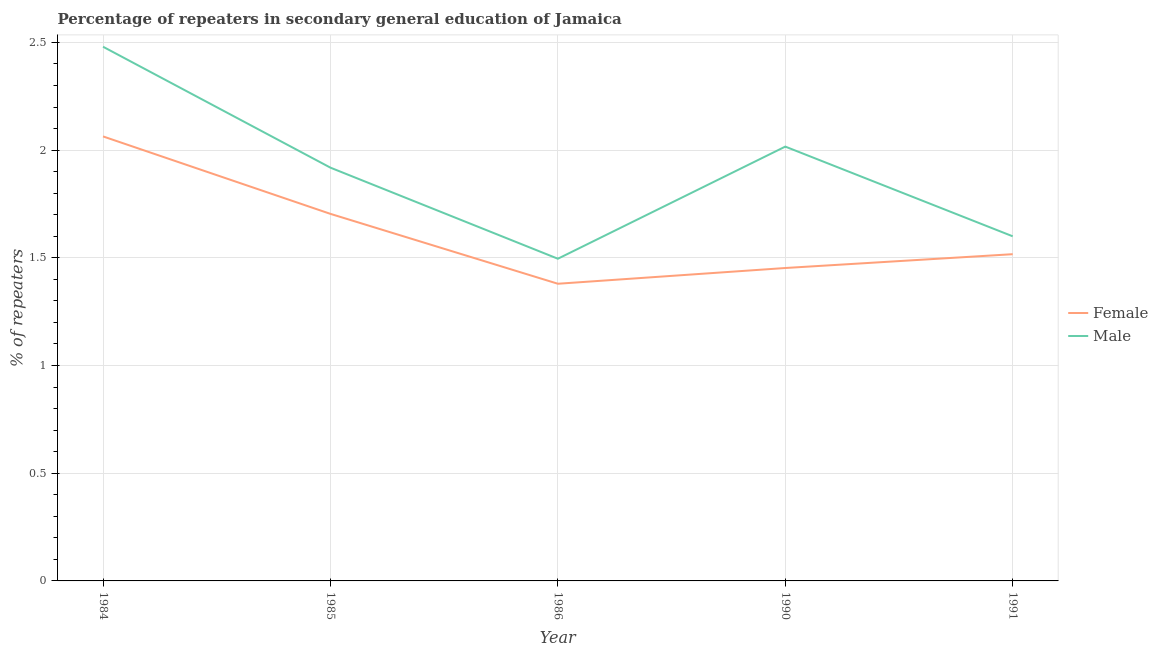How many different coloured lines are there?
Keep it short and to the point. 2. Does the line corresponding to percentage of male repeaters intersect with the line corresponding to percentage of female repeaters?
Your answer should be compact. No. What is the percentage of female repeaters in 1990?
Give a very brief answer. 1.45. Across all years, what is the maximum percentage of female repeaters?
Your answer should be compact. 2.06. Across all years, what is the minimum percentage of female repeaters?
Give a very brief answer. 1.38. In which year was the percentage of female repeaters minimum?
Offer a very short reply. 1986. What is the total percentage of female repeaters in the graph?
Your response must be concise. 8.12. What is the difference between the percentage of male repeaters in 1984 and that in 1986?
Offer a terse response. 0.98. What is the difference between the percentage of female repeaters in 1990 and the percentage of male repeaters in 1985?
Your answer should be very brief. -0.47. What is the average percentage of female repeaters per year?
Offer a terse response. 1.62. In the year 1985, what is the difference between the percentage of male repeaters and percentage of female repeaters?
Your response must be concise. 0.21. In how many years, is the percentage of female repeaters greater than 1.8 %?
Your response must be concise. 1. What is the ratio of the percentage of female repeaters in 1985 to that in 1990?
Offer a very short reply. 1.17. Is the percentage of female repeaters in 1985 less than that in 1990?
Ensure brevity in your answer.  No. What is the difference between the highest and the second highest percentage of male repeaters?
Offer a very short reply. 0.46. What is the difference between the highest and the lowest percentage of male repeaters?
Provide a short and direct response. 0.98. Is the sum of the percentage of male repeaters in 1985 and 1986 greater than the maximum percentage of female repeaters across all years?
Offer a terse response. Yes. Does the percentage of male repeaters monotonically increase over the years?
Ensure brevity in your answer.  No. Is the percentage of male repeaters strictly less than the percentage of female repeaters over the years?
Offer a very short reply. No. How many years are there in the graph?
Your answer should be very brief. 5. What is the difference between two consecutive major ticks on the Y-axis?
Keep it short and to the point. 0.5. Where does the legend appear in the graph?
Offer a very short reply. Center right. What is the title of the graph?
Ensure brevity in your answer.  Percentage of repeaters in secondary general education of Jamaica. What is the label or title of the Y-axis?
Offer a terse response. % of repeaters. What is the % of repeaters in Female in 1984?
Keep it short and to the point. 2.06. What is the % of repeaters in Male in 1984?
Keep it short and to the point. 2.48. What is the % of repeaters of Female in 1985?
Your answer should be compact. 1.7. What is the % of repeaters in Male in 1985?
Give a very brief answer. 1.92. What is the % of repeaters of Female in 1986?
Keep it short and to the point. 1.38. What is the % of repeaters in Male in 1986?
Give a very brief answer. 1.5. What is the % of repeaters of Female in 1990?
Provide a succinct answer. 1.45. What is the % of repeaters of Male in 1990?
Provide a succinct answer. 2.02. What is the % of repeaters in Female in 1991?
Your response must be concise. 1.52. What is the % of repeaters of Male in 1991?
Provide a succinct answer. 1.6. Across all years, what is the maximum % of repeaters in Female?
Give a very brief answer. 2.06. Across all years, what is the maximum % of repeaters of Male?
Make the answer very short. 2.48. Across all years, what is the minimum % of repeaters in Female?
Ensure brevity in your answer.  1.38. Across all years, what is the minimum % of repeaters of Male?
Provide a succinct answer. 1.5. What is the total % of repeaters of Female in the graph?
Offer a very short reply. 8.12. What is the total % of repeaters of Male in the graph?
Offer a terse response. 9.51. What is the difference between the % of repeaters of Female in 1984 and that in 1985?
Provide a short and direct response. 0.36. What is the difference between the % of repeaters in Male in 1984 and that in 1985?
Keep it short and to the point. 0.56. What is the difference between the % of repeaters of Female in 1984 and that in 1986?
Offer a terse response. 0.68. What is the difference between the % of repeaters of Male in 1984 and that in 1986?
Your response must be concise. 0.98. What is the difference between the % of repeaters in Female in 1984 and that in 1990?
Keep it short and to the point. 0.61. What is the difference between the % of repeaters of Male in 1984 and that in 1990?
Provide a short and direct response. 0.46. What is the difference between the % of repeaters in Female in 1984 and that in 1991?
Keep it short and to the point. 0.55. What is the difference between the % of repeaters of Male in 1984 and that in 1991?
Ensure brevity in your answer.  0.88. What is the difference between the % of repeaters of Female in 1985 and that in 1986?
Give a very brief answer. 0.32. What is the difference between the % of repeaters in Male in 1985 and that in 1986?
Your answer should be compact. 0.42. What is the difference between the % of repeaters of Female in 1985 and that in 1990?
Make the answer very short. 0.25. What is the difference between the % of repeaters of Male in 1985 and that in 1990?
Provide a succinct answer. -0.1. What is the difference between the % of repeaters of Female in 1985 and that in 1991?
Give a very brief answer. 0.19. What is the difference between the % of repeaters in Male in 1985 and that in 1991?
Provide a short and direct response. 0.32. What is the difference between the % of repeaters in Female in 1986 and that in 1990?
Your answer should be very brief. -0.07. What is the difference between the % of repeaters in Male in 1986 and that in 1990?
Your answer should be very brief. -0.52. What is the difference between the % of repeaters of Female in 1986 and that in 1991?
Your answer should be very brief. -0.14. What is the difference between the % of repeaters in Male in 1986 and that in 1991?
Ensure brevity in your answer.  -0.1. What is the difference between the % of repeaters of Female in 1990 and that in 1991?
Offer a terse response. -0.06. What is the difference between the % of repeaters of Male in 1990 and that in 1991?
Your response must be concise. 0.42. What is the difference between the % of repeaters of Female in 1984 and the % of repeaters of Male in 1985?
Your answer should be very brief. 0.15. What is the difference between the % of repeaters in Female in 1984 and the % of repeaters in Male in 1986?
Your answer should be very brief. 0.57. What is the difference between the % of repeaters in Female in 1984 and the % of repeaters in Male in 1990?
Ensure brevity in your answer.  0.05. What is the difference between the % of repeaters of Female in 1984 and the % of repeaters of Male in 1991?
Keep it short and to the point. 0.46. What is the difference between the % of repeaters in Female in 1985 and the % of repeaters in Male in 1986?
Your answer should be compact. 0.21. What is the difference between the % of repeaters in Female in 1985 and the % of repeaters in Male in 1990?
Your response must be concise. -0.31. What is the difference between the % of repeaters of Female in 1985 and the % of repeaters of Male in 1991?
Make the answer very short. 0.1. What is the difference between the % of repeaters in Female in 1986 and the % of repeaters in Male in 1990?
Your answer should be very brief. -0.64. What is the difference between the % of repeaters of Female in 1986 and the % of repeaters of Male in 1991?
Provide a succinct answer. -0.22. What is the difference between the % of repeaters in Female in 1990 and the % of repeaters in Male in 1991?
Provide a succinct answer. -0.15. What is the average % of repeaters of Female per year?
Your response must be concise. 1.62. What is the average % of repeaters in Male per year?
Your answer should be very brief. 1.9. In the year 1984, what is the difference between the % of repeaters of Female and % of repeaters of Male?
Provide a succinct answer. -0.42. In the year 1985, what is the difference between the % of repeaters in Female and % of repeaters in Male?
Your answer should be compact. -0.21. In the year 1986, what is the difference between the % of repeaters in Female and % of repeaters in Male?
Keep it short and to the point. -0.12. In the year 1990, what is the difference between the % of repeaters of Female and % of repeaters of Male?
Ensure brevity in your answer.  -0.56. In the year 1991, what is the difference between the % of repeaters in Female and % of repeaters in Male?
Offer a very short reply. -0.08. What is the ratio of the % of repeaters of Female in 1984 to that in 1985?
Your answer should be very brief. 1.21. What is the ratio of the % of repeaters in Male in 1984 to that in 1985?
Your response must be concise. 1.29. What is the ratio of the % of repeaters in Female in 1984 to that in 1986?
Ensure brevity in your answer.  1.5. What is the ratio of the % of repeaters in Male in 1984 to that in 1986?
Make the answer very short. 1.66. What is the ratio of the % of repeaters in Female in 1984 to that in 1990?
Offer a terse response. 1.42. What is the ratio of the % of repeaters in Male in 1984 to that in 1990?
Ensure brevity in your answer.  1.23. What is the ratio of the % of repeaters of Female in 1984 to that in 1991?
Give a very brief answer. 1.36. What is the ratio of the % of repeaters in Male in 1984 to that in 1991?
Offer a terse response. 1.55. What is the ratio of the % of repeaters of Female in 1985 to that in 1986?
Offer a very short reply. 1.24. What is the ratio of the % of repeaters of Male in 1985 to that in 1986?
Keep it short and to the point. 1.28. What is the ratio of the % of repeaters in Female in 1985 to that in 1990?
Your response must be concise. 1.17. What is the ratio of the % of repeaters in Male in 1985 to that in 1990?
Provide a short and direct response. 0.95. What is the ratio of the % of repeaters in Female in 1985 to that in 1991?
Offer a terse response. 1.12. What is the ratio of the % of repeaters in Male in 1985 to that in 1991?
Your answer should be compact. 1.2. What is the ratio of the % of repeaters of Female in 1986 to that in 1990?
Give a very brief answer. 0.95. What is the ratio of the % of repeaters of Male in 1986 to that in 1990?
Your response must be concise. 0.74. What is the ratio of the % of repeaters of Female in 1986 to that in 1991?
Make the answer very short. 0.91. What is the ratio of the % of repeaters in Male in 1986 to that in 1991?
Your response must be concise. 0.93. What is the ratio of the % of repeaters in Female in 1990 to that in 1991?
Your answer should be very brief. 0.96. What is the ratio of the % of repeaters in Male in 1990 to that in 1991?
Give a very brief answer. 1.26. What is the difference between the highest and the second highest % of repeaters of Female?
Your answer should be very brief. 0.36. What is the difference between the highest and the second highest % of repeaters of Male?
Your answer should be compact. 0.46. What is the difference between the highest and the lowest % of repeaters in Female?
Offer a terse response. 0.68. What is the difference between the highest and the lowest % of repeaters in Male?
Ensure brevity in your answer.  0.98. 